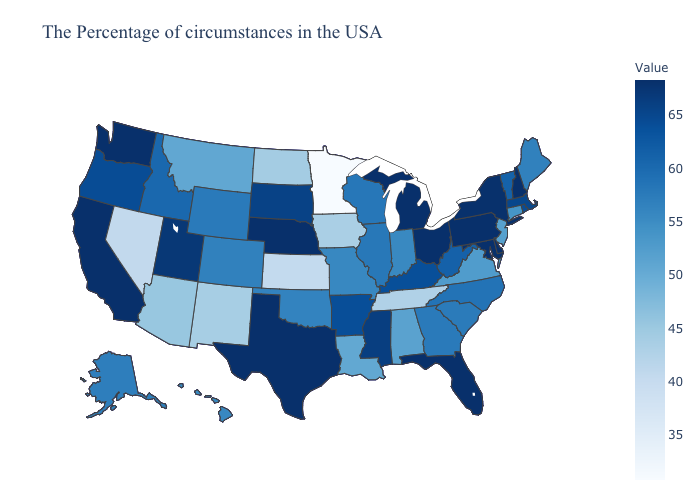Which states hav the highest value in the MidWest?
Be succinct. Ohio, Michigan, Nebraska. Does New York have the highest value in the Northeast?
Answer briefly. No. Among the states that border West Virginia , which have the highest value?
Give a very brief answer. Maryland, Pennsylvania, Ohio. Among the states that border Ohio , which have the lowest value?
Quick response, please. Indiana. Does Washington have the highest value in the USA?
Answer briefly. Yes. Among the states that border Virginia , does Tennessee have the lowest value?
Short answer required. Yes. 